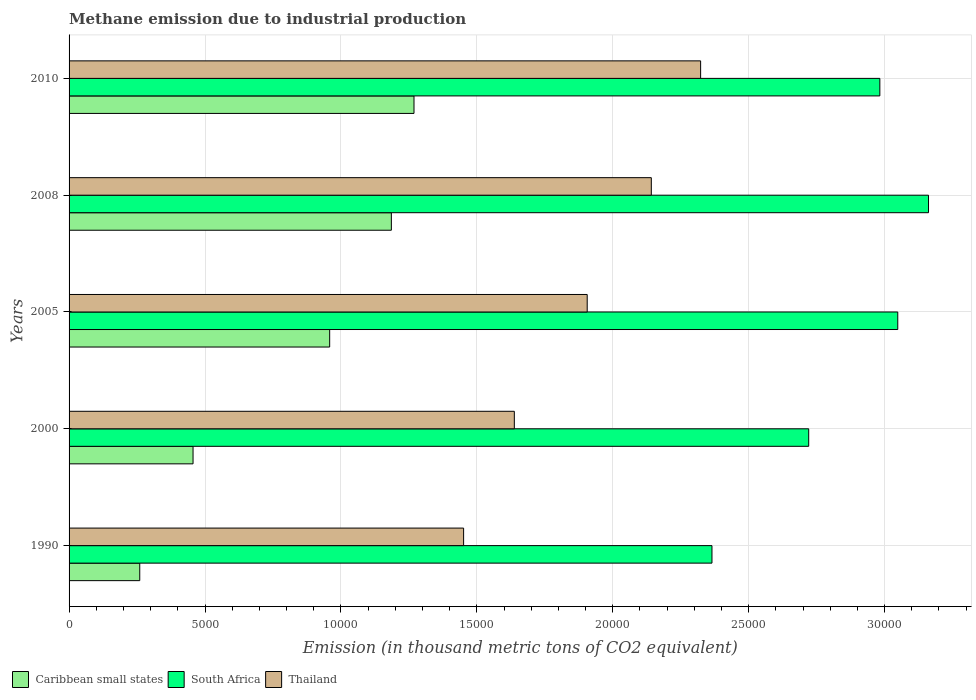How many different coloured bars are there?
Your answer should be compact. 3. How many groups of bars are there?
Your response must be concise. 5. Are the number of bars per tick equal to the number of legend labels?
Ensure brevity in your answer.  Yes. How many bars are there on the 2nd tick from the top?
Ensure brevity in your answer.  3. How many bars are there on the 5th tick from the bottom?
Offer a very short reply. 3. What is the label of the 5th group of bars from the top?
Your answer should be compact. 1990. In how many cases, is the number of bars for a given year not equal to the number of legend labels?
Make the answer very short. 0. What is the amount of methane emitted in Thailand in 2000?
Offer a very short reply. 1.64e+04. Across all years, what is the maximum amount of methane emitted in South Africa?
Offer a terse response. 3.16e+04. Across all years, what is the minimum amount of methane emitted in South Africa?
Ensure brevity in your answer.  2.36e+04. In which year was the amount of methane emitted in South Africa minimum?
Keep it short and to the point. 1990. What is the total amount of methane emitted in South Africa in the graph?
Your answer should be very brief. 1.43e+05. What is the difference between the amount of methane emitted in South Africa in 2005 and that in 2010?
Your answer should be compact. 659.6. What is the difference between the amount of methane emitted in South Africa in 2010 and the amount of methane emitted in Thailand in 2000?
Your answer should be compact. 1.34e+04. What is the average amount of methane emitted in South Africa per year?
Keep it short and to the point. 2.86e+04. In the year 2010, what is the difference between the amount of methane emitted in Thailand and amount of methane emitted in South Africa?
Make the answer very short. -6592.5. In how many years, is the amount of methane emitted in South Africa greater than 24000 thousand metric tons?
Provide a short and direct response. 4. What is the ratio of the amount of methane emitted in Caribbean small states in 1990 to that in 2008?
Provide a succinct answer. 0.22. Is the amount of methane emitted in Thailand in 2000 less than that in 2008?
Provide a succinct answer. Yes. Is the difference between the amount of methane emitted in Thailand in 1990 and 2008 greater than the difference between the amount of methane emitted in South Africa in 1990 and 2008?
Keep it short and to the point. Yes. What is the difference between the highest and the second highest amount of methane emitted in Caribbean small states?
Make the answer very short. 832.7. What is the difference between the highest and the lowest amount of methane emitted in South Africa?
Your answer should be very brief. 7965.9. What does the 1st bar from the top in 2010 represents?
Your answer should be compact. Thailand. What does the 2nd bar from the bottom in 2000 represents?
Your response must be concise. South Africa. Is it the case that in every year, the sum of the amount of methane emitted in Thailand and amount of methane emitted in Caribbean small states is greater than the amount of methane emitted in South Africa?
Your answer should be compact. No. Are all the bars in the graph horizontal?
Your answer should be very brief. Yes. What is the difference between two consecutive major ticks on the X-axis?
Your response must be concise. 5000. Are the values on the major ticks of X-axis written in scientific E-notation?
Keep it short and to the point. No. How many legend labels are there?
Ensure brevity in your answer.  3. What is the title of the graph?
Provide a succinct answer. Methane emission due to industrial production. What is the label or title of the X-axis?
Your answer should be very brief. Emission (in thousand metric tons of CO2 equivalent). What is the label or title of the Y-axis?
Provide a succinct answer. Years. What is the Emission (in thousand metric tons of CO2 equivalent) of Caribbean small states in 1990?
Offer a very short reply. 2599.9. What is the Emission (in thousand metric tons of CO2 equivalent) in South Africa in 1990?
Offer a very short reply. 2.36e+04. What is the Emission (in thousand metric tons of CO2 equivalent) of Thailand in 1990?
Your answer should be very brief. 1.45e+04. What is the Emission (in thousand metric tons of CO2 equivalent) of Caribbean small states in 2000?
Your answer should be very brief. 4560.6. What is the Emission (in thousand metric tons of CO2 equivalent) in South Africa in 2000?
Offer a terse response. 2.72e+04. What is the Emission (in thousand metric tons of CO2 equivalent) of Thailand in 2000?
Provide a succinct answer. 1.64e+04. What is the Emission (in thousand metric tons of CO2 equivalent) in Caribbean small states in 2005?
Offer a terse response. 9586.6. What is the Emission (in thousand metric tons of CO2 equivalent) in South Africa in 2005?
Ensure brevity in your answer.  3.05e+04. What is the Emission (in thousand metric tons of CO2 equivalent) in Thailand in 2005?
Your response must be concise. 1.91e+04. What is the Emission (in thousand metric tons of CO2 equivalent) of Caribbean small states in 2008?
Offer a terse response. 1.19e+04. What is the Emission (in thousand metric tons of CO2 equivalent) in South Africa in 2008?
Offer a very short reply. 3.16e+04. What is the Emission (in thousand metric tons of CO2 equivalent) of Thailand in 2008?
Ensure brevity in your answer.  2.14e+04. What is the Emission (in thousand metric tons of CO2 equivalent) of Caribbean small states in 2010?
Your response must be concise. 1.27e+04. What is the Emission (in thousand metric tons of CO2 equivalent) in South Africa in 2010?
Provide a short and direct response. 2.98e+04. What is the Emission (in thousand metric tons of CO2 equivalent) in Thailand in 2010?
Offer a terse response. 2.32e+04. Across all years, what is the maximum Emission (in thousand metric tons of CO2 equivalent) in Caribbean small states?
Your answer should be very brief. 1.27e+04. Across all years, what is the maximum Emission (in thousand metric tons of CO2 equivalent) in South Africa?
Make the answer very short. 3.16e+04. Across all years, what is the maximum Emission (in thousand metric tons of CO2 equivalent) of Thailand?
Offer a very short reply. 2.32e+04. Across all years, what is the minimum Emission (in thousand metric tons of CO2 equivalent) of Caribbean small states?
Make the answer very short. 2599.9. Across all years, what is the minimum Emission (in thousand metric tons of CO2 equivalent) in South Africa?
Your answer should be very brief. 2.36e+04. Across all years, what is the minimum Emission (in thousand metric tons of CO2 equivalent) in Thailand?
Keep it short and to the point. 1.45e+04. What is the total Emission (in thousand metric tons of CO2 equivalent) of Caribbean small states in the graph?
Offer a terse response. 4.13e+04. What is the total Emission (in thousand metric tons of CO2 equivalent) of South Africa in the graph?
Ensure brevity in your answer.  1.43e+05. What is the total Emission (in thousand metric tons of CO2 equivalent) in Thailand in the graph?
Your answer should be compact. 9.46e+04. What is the difference between the Emission (in thousand metric tons of CO2 equivalent) of Caribbean small states in 1990 and that in 2000?
Provide a succinct answer. -1960.7. What is the difference between the Emission (in thousand metric tons of CO2 equivalent) in South Africa in 1990 and that in 2000?
Your answer should be very brief. -3558.3. What is the difference between the Emission (in thousand metric tons of CO2 equivalent) in Thailand in 1990 and that in 2000?
Offer a terse response. -1865.4. What is the difference between the Emission (in thousand metric tons of CO2 equivalent) in Caribbean small states in 1990 and that in 2005?
Your answer should be compact. -6986.7. What is the difference between the Emission (in thousand metric tons of CO2 equivalent) of South Africa in 1990 and that in 2005?
Offer a very short reply. -6834.8. What is the difference between the Emission (in thousand metric tons of CO2 equivalent) of Thailand in 1990 and that in 2005?
Offer a very short reply. -4546.4. What is the difference between the Emission (in thousand metric tons of CO2 equivalent) of Caribbean small states in 1990 and that in 2008?
Provide a short and direct response. -9255.6. What is the difference between the Emission (in thousand metric tons of CO2 equivalent) in South Africa in 1990 and that in 2008?
Offer a terse response. -7965.9. What is the difference between the Emission (in thousand metric tons of CO2 equivalent) in Thailand in 1990 and that in 2008?
Make the answer very short. -6904.8. What is the difference between the Emission (in thousand metric tons of CO2 equivalent) of Caribbean small states in 1990 and that in 2010?
Make the answer very short. -1.01e+04. What is the difference between the Emission (in thousand metric tons of CO2 equivalent) of South Africa in 1990 and that in 2010?
Give a very brief answer. -6175.2. What is the difference between the Emission (in thousand metric tons of CO2 equivalent) in Thailand in 1990 and that in 2010?
Provide a succinct answer. -8718.6. What is the difference between the Emission (in thousand metric tons of CO2 equivalent) of Caribbean small states in 2000 and that in 2005?
Your response must be concise. -5026. What is the difference between the Emission (in thousand metric tons of CO2 equivalent) of South Africa in 2000 and that in 2005?
Your answer should be compact. -3276.5. What is the difference between the Emission (in thousand metric tons of CO2 equivalent) of Thailand in 2000 and that in 2005?
Give a very brief answer. -2681. What is the difference between the Emission (in thousand metric tons of CO2 equivalent) of Caribbean small states in 2000 and that in 2008?
Give a very brief answer. -7294.9. What is the difference between the Emission (in thousand metric tons of CO2 equivalent) of South Africa in 2000 and that in 2008?
Give a very brief answer. -4407.6. What is the difference between the Emission (in thousand metric tons of CO2 equivalent) in Thailand in 2000 and that in 2008?
Provide a succinct answer. -5039.4. What is the difference between the Emission (in thousand metric tons of CO2 equivalent) of Caribbean small states in 2000 and that in 2010?
Your response must be concise. -8127.6. What is the difference between the Emission (in thousand metric tons of CO2 equivalent) of South Africa in 2000 and that in 2010?
Offer a terse response. -2616.9. What is the difference between the Emission (in thousand metric tons of CO2 equivalent) of Thailand in 2000 and that in 2010?
Your response must be concise. -6853.2. What is the difference between the Emission (in thousand metric tons of CO2 equivalent) in Caribbean small states in 2005 and that in 2008?
Provide a short and direct response. -2268.9. What is the difference between the Emission (in thousand metric tons of CO2 equivalent) of South Africa in 2005 and that in 2008?
Your response must be concise. -1131.1. What is the difference between the Emission (in thousand metric tons of CO2 equivalent) of Thailand in 2005 and that in 2008?
Your answer should be very brief. -2358.4. What is the difference between the Emission (in thousand metric tons of CO2 equivalent) in Caribbean small states in 2005 and that in 2010?
Provide a succinct answer. -3101.6. What is the difference between the Emission (in thousand metric tons of CO2 equivalent) of South Africa in 2005 and that in 2010?
Ensure brevity in your answer.  659.6. What is the difference between the Emission (in thousand metric tons of CO2 equivalent) in Thailand in 2005 and that in 2010?
Offer a terse response. -4172.2. What is the difference between the Emission (in thousand metric tons of CO2 equivalent) in Caribbean small states in 2008 and that in 2010?
Keep it short and to the point. -832.7. What is the difference between the Emission (in thousand metric tons of CO2 equivalent) of South Africa in 2008 and that in 2010?
Give a very brief answer. 1790.7. What is the difference between the Emission (in thousand metric tons of CO2 equivalent) of Thailand in 2008 and that in 2010?
Your answer should be compact. -1813.8. What is the difference between the Emission (in thousand metric tons of CO2 equivalent) of Caribbean small states in 1990 and the Emission (in thousand metric tons of CO2 equivalent) of South Africa in 2000?
Make the answer very short. -2.46e+04. What is the difference between the Emission (in thousand metric tons of CO2 equivalent) of Caribbean small states in 1990 and the Emission (in thousand metric tons of CO2 equivalent) of Thailand in 2000?
Provide a short and direct response. -1.38e+04. What is the difference between the Emission (in thousand metric tons of CO2 equivalent) in South Africa in 1990 and the Emission (in thousand metric tons of CO2 equivalent) in Thailand in 2000?
Ensure brevity in your answer.  7270.5. What is the difference between the Emission (in thousand metric tons of CO2 equivalent) of Caribbean small states in 1990 and the Emission (in thousand metric tons of CO2 equivalent) of South Africa in 2005?
Offer a terse response. -2.79e+04. What is the difference between the Emission (in thousand metric tons of CO2 equivalent) of Caribbean small states in 1990 and the Emission (in thousand metric tons of CO2 equivalent) of Thailand in 2005?
Make the answer very short. -1.65e+04. What is the difference between the Emission (in thousand metric tons of CO2 equivalent) in South Africa in 1990 and the Emission (in thousand metric tons of CO2 equivalent) in Thailand in 2005?
Ensure brevity in your answer.  4589.5. What is the difference between the Emission (in thousand metric tons of CO2 equivalent) in Caribbean small states in 1990 and the Emission (in thousand metric tons of CO2 equivalent) in South Africa in 2008?
Offer a very short reply. -2.90e+04. What is the difference between the Emission (in thousand metric tons of CO2 equivalent) in Caribbean small states in 1990 and the Emission (in thousand metric tons of CO2 equivalent) in Thailand in 2008?
Provide a short and direct response. -1.88e+04. What is the difference between the Emission (in thousand metric tons of CO2 equivalent) of South Africa in 1990 and the Emission (in thousand metric tons of CO2 equivalent) of Thailand in 2008?
Your answer should be very brief. 2231.1. What is the difference between the Emission (in thousand metric tons of CO2 equivalent) in Caribbean small states in 1990 and the Emission (in thousand metric tons of CO2 equivalent) in South Africa in 2010?
Make the answer very short. -2.72e+04. What is the difference between the Emission (in thousand metric tons of CO2 equivalent) in Caribbean small states in 1990 and the Emission (in thousand metric tons of CO2 equivalent) in Thailand in 2010?
Provide a short and direct response. -2.06e+04. What is the difference between the Emission (in thousand metric tons of CO2 equivalent) of South Africa in 1990 and the Emission (in thousand metric tons of CO2 equivalent) of Thailand in 2010?
Provide a short and direct response. 417.3. What is the difference between the Emission (in thousand metric tons of CO2 equivalent) of Caribbean small states in 2000 and the Emission (in thousand metric tons of CO2 equivalent) of South Africa in 2005?
Keep it short and to the point. -2.59e+04. What is the difference between the Emission (in thousand metric tons of CO2 equivalent) in Caribbean small states in 2000 and the Emission (in thousand metric tons of CO2 equivalent) in Thailand in 2005?
Your response must be concise. -1.45e+04. What is the difference between the Emission (in thousand metric tons of CO2 equivalent) in South Africa in 2000 and the Emission (in thousand metric tons of CO2 equivalent) in Thailand in 2005?
Your answer should be very brief. 8147.8. What is the difference between the Emission (in thousand metric tons of CO2 equivalent) of Caribbean small states in 2000 and the Emission (in thousand metric tons of CO2 equivalent) of South Africa in 2008?
Provide a succinct answer. -2.71e+04. What is the difference between the Emission (in thousand metric tons of CO2 equivalent) of Caribbean small states in 2000 and the Emission (in thousand metric tons of CO2 equivalent) of Thailand in 2008?
Give a very brief answer. -1.69e+04. What is the difference between the Emission (in thousand metric tons of CO2 equivalent) in South Africa in 2000 and the Emission (in thousand metric tons of CO2 equivalent) in Thailand in 2008?
Your response must be concise. 5789.4. What is the difference between the Emission (in thousand metric tons of CO2 equivalent) of Caribbean small states in 2000 and the Emission (in thousand metric tons of CO2 equivalent) of South Africa in 2010?
Keep it short and to the point. -2.53e+04. What is the difference between the Emission (in thousand metric tons of CO2 equivalent) in Caribbean small states in 2000 and the Emission (in thousand metric tons of CO2 equivalent) in Thailand in 2010?
Your response must be concise. -1.87e+04. What is the difference between the Emission (in thousand metric tons of CO2 equivalent) in South Africa in 2000 and the Emission (in thousand metric tons of CO2 equivalent) in Thailand in 2010?
Ensure brevity in your answer.  3975.6. What is the difference between the Emission (in thousand metric tons of CO2 equivalent) in Caribbean small states in 2005 and the Emission (in thousand metric tons of CO2 equivalent) in South Africa in 2008?
Offer a very short reply. -2.20e+04. What is the difference between the Emission (in thousand metric tons of CO2 equivalent) of Caribbean small states in 2005 and the Emission (in thousand metric tons of CO2 equivalent) of Thailand in 2008?
Ensure brevity in your answer.  -1.18e+04. What is the difference between the Emission (in thousand metric tons of CO2 equivalent) of South Africa in 2005 and the Emission (in thousand metric tons of CO2 equivalent) of Thailand in 2008?
Offer a terse response. 9065.9. What is the difference between the Emission (in thousand metric tons of CO2 equivalent) of Caribbean small states in 2005 and the Emission (in thousand metric tons of CO2 equivalent) of South Africa in 2010?
Your response must be concise. -2.02e+04. What is the difference between the Emission (in thousand metric tons of CO2 equivalent) of Caribbean small states in 2005 and the Emission (in thousand metric tons of CO2 equivalent) of Thailand in 2010?
Make the answer very short. -1.36e+04. What is the difference between the Emission (in thousand metric tons of CO2 equivalent) of South Africa in 2005 and the Emission (in thousand metric tons of CO2 equivalent) of Thailand in 2010?
Provide a succinct answer. 7252.1. What is the difference between the Emission (in thousand metric tons of CO2 equivalent) of Caribbean small states in 2008 and the Emission (in thousand metric tons of CO2 equivalent) of South Africa in 2010?
Provide a succinct answer. -1.80e+04. What is the difference between the Emission (in thousand metric tons of CO2 equivalent) of Caribbean small states in 2008 and the Emission (in thousand metric tons of CO2 equivalent) of Thailand in 2010?
Your answer should be very brief. -1.14e+04. What is the difference between the Emission (in thousand metric tons of CO2 equivalent) in South Africa in 2008 and the Emission (in thousand metric tons of CO2 equivalent) in Thailand in 2010?
Your response must be concise. 8383.2. What is the average Emission (in thousand metric tons of CO2 equivalent) in Caribbean small states per year?
Your answer should be compact. 8258.16. What is the average Emission (in thousand metric tons of CO2 equivalent) in South Africa per year?
Keep it short and to the point. 2.86e+04. What is the average Emission (in thousand metric tons of CO2 equivalent) of Thailand per year?
Keep it short and to the point. 1.89e+04. In the year 1990, what is the difference between the Emission (in thousand metric tons of CO2 equivalent) in Caribbean small states and Emission (in thousand metric tons of CO2 equivalent) in South Africa?
Your answer should be very brief. -2.10e+04. In the year 1990, what is the difference between the Emission (in thousand metric tons of CO2 equivalent) of Caribbean small states and Emission (in thousand metric tons of CO2 equivalent) of Thailand?
Give a very brief answer. -1.19e+04. In the year 1990, what is the difference between the Emission (in thousand metric tons of CO2 equivalent) of South Africa and Emission (in thousand metric tons of CO2 equivalent) of Thailand?
Make the answer very short. 9135.9. In the year 2000, what is the difference between the Emission (in thousand metric tons of CO2 equivalent) of Caribbean small states and Emission (in thousand metric tons of CO2 equivalent) of South Africa?
Make the answer very short. -2.26e+04. In the year 2000, what is the difference between the Emission (in thousand metric tons of CO2 equivalent) in Caribbean small states and Emission (in thousand metric tons of CO2 equivalent) in Thailand?
Your answer should be compact. -1.18e+04. In the year 2000, what is the difference between the Emission (in thousand metric tons of CO2 equivalent) in South Africa and Emission (in thousand metric tons of CO2 equivalent) in Thailand?
Your answer should be very brief. 1.08e+04. In the year 2005, what is the difference between the Emission (in thousand metric tons of CO2 equivalent) in Caribbean small states and Emission (in thousand metric tons of CO2 equivalent) in South Africa?
Your response must be concise. -2.09e+04. In the year 2005, what is the difference between the Emission (in thousand metric tons of CO2 equivalent) in Caribbean small states and Emission (in thousand metric tons of CO2 equivalent) in Thailand?
Your response must be concise. -9473.4. In the year 2005, what is the difference between the Emission (in thousand metric tons of CO2 equivalent) in South Africa and Emission (in thousand metric tons of CO2 equivalent) in Thailand?
Give a very brief answer. 1.14e+04. In the year 2008, what is the difference between the Emission (in thousand metric tons of CO2 equivalent) of Caribbean small states and Emission (in thousand metric tons of CO2 equivalent) of South Africa?
Make the answer very short. -1.98e+04. In the year 2008, what is the difference between the Emission (in thousand metric tons of CO2 equivalent) in Caribbean small states and Emission (in thousand metric tons of CO2 equivalent) in Thailand?
Your answer should be compact. -9562.9. In the year 2008, what is the difference between the Emission (in thousand metric tons of CO2 equivalent) of South Africa and Emission (in thousand metric tons of CO2 equivalent) of Thailand?
Keep it short and to the point. 1.02e+04. In the year 2010, what is the difference between the Emission (in thousand metric tons of CO2 equivalent) of Caribbean small states and Emission (in thousand metric tons of CO2 equivalent) of South Africa?
Provide a short and direct response. -1.71e+04. In the year 2010, what is the difference between the Emission (in thousand metric tons of CO2 equivalent) in Caribbean small states and Emission (in thousand metric tons of CO2 equivalent) in Thailand?
Ensure brevity in your answer.  -1.05e+04. In the year 2010, what is the difference between the Emission (in thousand metric tons of CO2 equivalent) of South Africa and Emission (in thousand metric tons of CO2 equivalent) of Thailand?
Make the answer very short. 6592.5. What is the ratio of the Emission (in thousand metric tons of CO2 equivalent) in Caribbean small states in 1990 to that in 2000?
Your answer should be very brief. 0.57. What is the ratio of the Emission (in thousand metric tons of CO2 equivalent) of South Africa in 1990 to that in 2000?
Offer a very short reply. 0.87. What is the ratio of the Emission (in thousand metric tons of CO2 equivalent) of Thailand in 1990 to that in 2000?
Your answer should be very brief. 0.89. What is the ratio of the Emission (in thousand metric tons of CO2 equivalent) in Caribbean small states in 1990 to that in 2005?
Your answer should be very brief. 0.27. What is the ratio of the Emission (in thousand metric tons of CO2 equivalent) in South Africa in 1990 to that in 2005?
Provide a short and direct response. 0.78. What is the ratio of the Emission (in thousand metric tons of CO2 equivalent) of Thailand in 1990 to that in 2005?
Make the answer very short. 0.76. What is the ratio of the Emission (in thousand metric tons of CO2 equivalent) of Caribbean small states in 1990 to that in 2008?
Offer a terse response. 0.22. What is the ratio of the Emission (in thousand metric tons of CO2 equivalent) in South Africa in 1990 to that in 2008?
Your answer should be compact. 0.75. What is the ratio of the Emission (in thousand metric tons of CO2 equivalent) of Thailand in 1990 to that in 2008?
Make the answer very short. 0.68. What is the ratio of the Emission (in thousand metric tons of CO2 equivalent) of Caribbean small states in 1990 to that in 2010?
Offer a terse response. 0.2. What is the ratio of the Emission (in thousand metric tons of CO2 equivalent) in South Africa in 1990 to that in 2010?
Offer a very short reply. 0.79. What is the ratio of the Emission (in thousand metric tons of CO2 equivalent) in Thailand in 1990 to that in 2010?
Your response must be concise. 0.62. What is the ratio of the Emission (in thousand metric tons of CO2 equivalent) in Caribbean small states in 2000 to that in 2005?
Provide a succinct answer. 0.48. What is the ratio of the Emission (in thousand metric tons of CO2 equivalent) of South Africa in 2000 to that in 2005?
Offer a terse response. 0.89. What is the ratio of the Emission (in thousand metric tons of CO2 equivalent) of Thailand in 2000 to that in 2005?
Your answer should be very brief. 0.86. What is the ratio of the Emission (in thousand metric tons of CO2 equivalent) in Caribbean small states in 2000 to that in 2008?
Your answer should be very brief. 0.38. What is the ratio of the Emission (in thousand metric tons of CO2 equivalent) in South Africa in 2000 to that in 2008?
Make the answer very short. 0.86. What is the ratio of the Emission (in thousand metric tons of CO2 equivalent) of Thailand in 2000 to that in 2008?
Your response must be concise. 0.76. What is the ratio of the Emission (in thousand metric tons of CO2 equivalent) in Caribbean small states in 2000 to that in 2010?
Make the answer very short. 0.36. What is the ratio of the Emission (in thousand metric tons of CO2 equivalent) of South Africa in 2000 to that in 2010?
Your response must be concise. 0.91. What is the ratio of the Emission (in thousand metric tons of CO2 equivalent) in Thailand in 2000 to that in 2010?
Make the answer very short. 0.7. What is the ratio of the Emission (in thousand metric tons of CO2 equivalent) in Caribbean small states in 2005 to that in 2008?
Ensure brevity in your answer.  0.81. What is the ratio of the Emission (in thousand metric tons of CO2 equivalent) of South Africa in 2005 to that in 2008?
Your answer should be compact. 0.96. What is the ratio of the Emission (in thousand metric tons of CO2 equivalent) in Thailand in 2005 to that in 2008?
Offer a terse response. 0.89. What is the ratio of the Emission (in thousand metric tons of CO2 equivalent) in Caribbean small states in 2005 to that in 2010?
Provide a short and direct response. 0.76. What is the ratio of the Emission (in thousand metric tons of CO2 equivalent) in South Africa in 2005 to that in 2010?
Offer a very short reply. 1.02. What is the ratio of the Emission (in thousand metric tons of CO2 equivalent) in Thailand in 2005 to that in 2010?
Keep it short and to the point. 0.82. What is the ratio of the Emission (in thousand metric tons of CO2 equivalent) in Caribbean small states in 2008 to that in 2010?
Provide a succinct answer. 0.93. What is the ratio of the Emission (in thousand metric tons of CO2 equivalent) of South Africa in 2008 to that in 2010?
Your response must be concise. 1.06. What is the ratio of the Emission (in thousand metric tons of CO2 equivalent) of Thailand in 2008 to that in 2010?
Offer a terse response. 0.92. What is the difference between the highest and the second highest Emission (in thousand metric tons of CO2 equivalent) of Caribbean small states?
Your answer should be compact. 832.7. What is the difference between the highest and the second highest Emission (in thousand metric tons of CO2 equivalent) of South Africa?
Ensure brevity in your answer.  1131.1. What is the difference between the highest and the second highest Emission (in thousand metric tons of CO2 equivalent) of Thailand?
Keep it short and to the point. 1813.8. What is the difference between the highest and the lowest Emission (in thousand metric tons of CO2 equivalent) in Caribbean small states?
Offer a very short reply. 1.01e+04. What is the difference between the highest and the lowest Emission (in thousand metric tons of CO2 equivalent) of South Africa?
Provide a short and direct response. 7965.9. What is the difference between the highest and the lowest Emission (in thousand metric tons of CO2 equivalent) in Thailand?
Your answer should be very brief. 8718.6. 